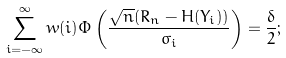Convert formula to latex. <formula><loc_0><loc_0><loc_500><loc_500>\sum _ { i = - \infty } ^ { \infty } w ( i ) \Phi \left ( \frac { \sqrt { n } ( R _ { n } - H ( Y _ { i } ) ) } { \sigma _ { i } } \right ) = \frac { \delta } { 2 } ;</formula> 